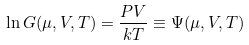Convert formula to latex. <formula><loc_0><loc_0><loc_500><loc_500>\ln G ( \mu , V , T ) = \frac { P V } { k T } \equiv \Psi ( \mu , V , T )</formula> 